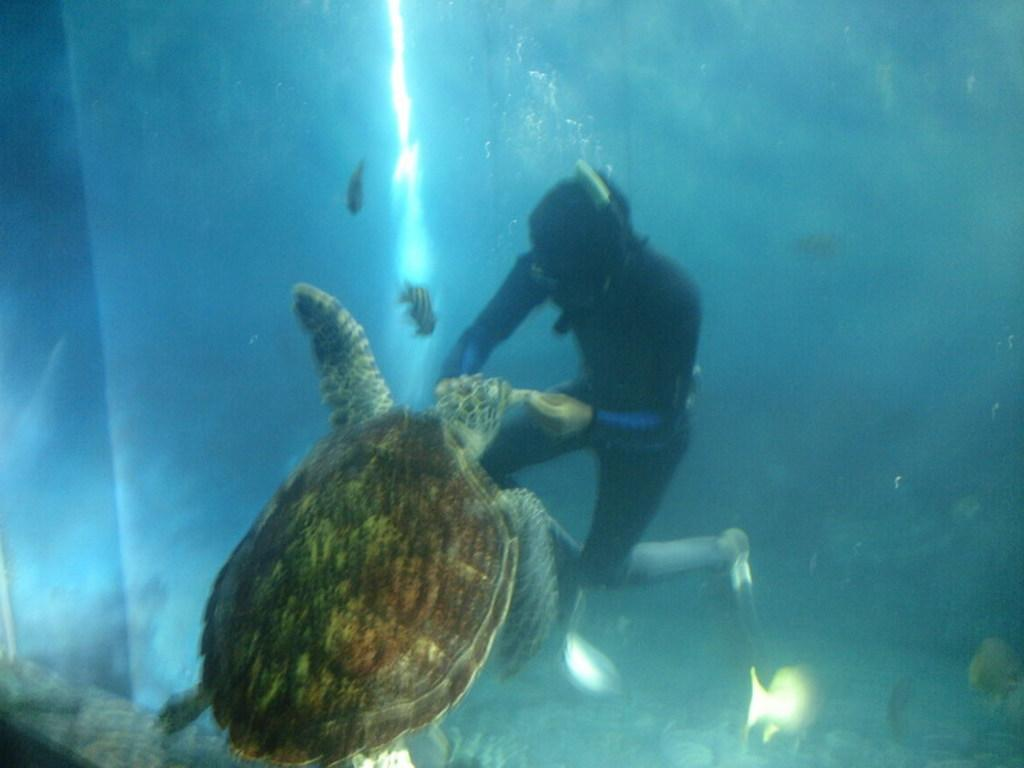Who or what is the main subject in the image? There is a person in the image. What is the person interacting with in the image? The person is interacting with a tortoise in the water in the image. What else can be seen in the water in the image? Fishes are visible in the background of the image. What is the price of the fifth fish in the image? There is no mention of a price or a fifth fish in the image; it only shows a person, a tortoise, and fishes in the water. 